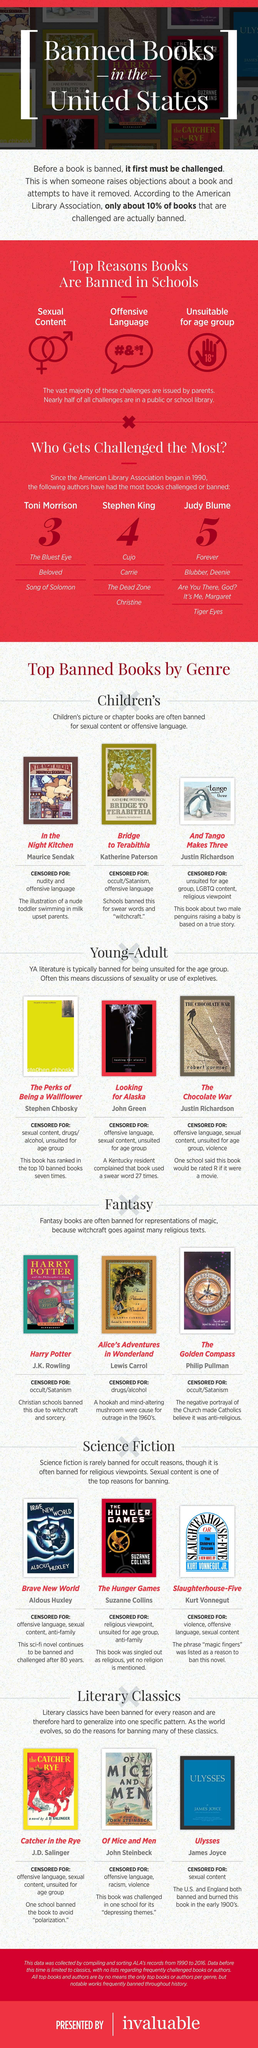Give some essential details in this illustration. Toni Morrison's banned books include "The Bluest Eye," "Beloved," and "Song of Solomon. The infographic lists several fantasy books that were banned due to their occult and/or Satanic themes, including Harry Potter and The Golden Compass. The top reasons to ban a book in school are sexual content, offensive language, and unsuitability for the age group. 